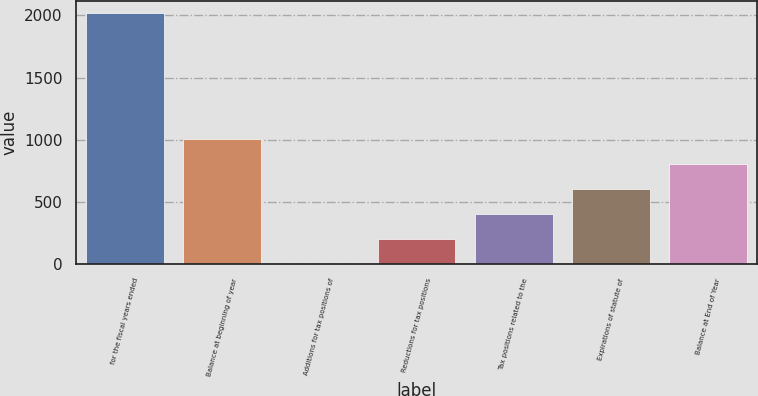<chart> <loc_0><loc_0><loc_500><loc_500><bar_chart><fcel>for the fiscal years ended<fcel>Balance at beginning of year<fcel>Additions for tax positions of<fcel>Reductions for tax positions<fcel>Tax positions related to the<fcel>Expirations of statute of<fcel>Balance at End of Year<nl><fcel>2016<fcel>1008.3<fcel>0.6<fcel>202.14<fcel>403.68<fcel>605.22<fcel>806.76<nl></chart> 